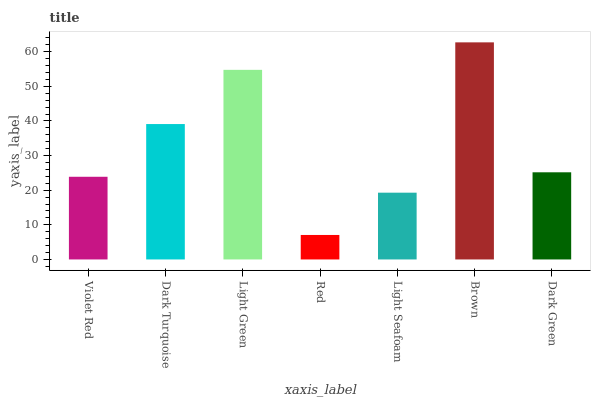Is Red the minimum?
Answer yes or no. Yes. Is Brown the maximum?
Answer yes or no. Yes. Is Dark Turquoise the minimum?
Answer yes or no. No. Is Dark Turquoise the maximum?
Answer yes or no. No. Is Dark Turquoise greater than Violet Red?
Answer yes or no. Yes. Is Violet Red less than Dark Turquoise?
Answer yes or no. Yes. Is Violet Red greater than Dark Turquoise?
Answer yes or no. No. Is Dark Turquoise less than Violet Red?
Answer yes or no. No. Is Dark Green the high median?
Answer yes or no. Yes. Is Dark Green the low median?
Answer yes or no. Yes. Is Light Seafoam the high median?
Answer yes or no. No. Is Light Seafoam the low median?
Answer yes or no. No. 